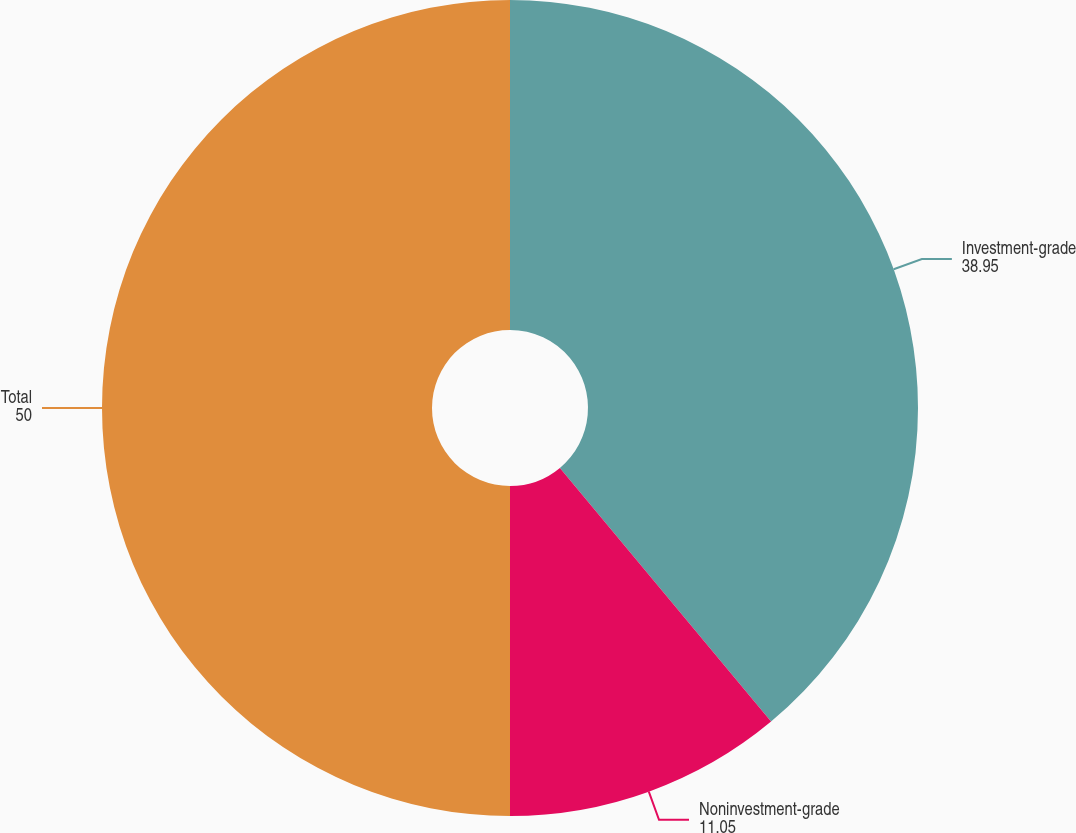Convert chart to OTSL. <chart><loc_0><loc_0><loc_500><loc_500><pie_chart><fcel>Investment-grade<fcel>Noninvestment-grade<fcel>Total<nl><fcel>38.95%<fcel>11.05%<fcel>50.0%<nl></chart> 